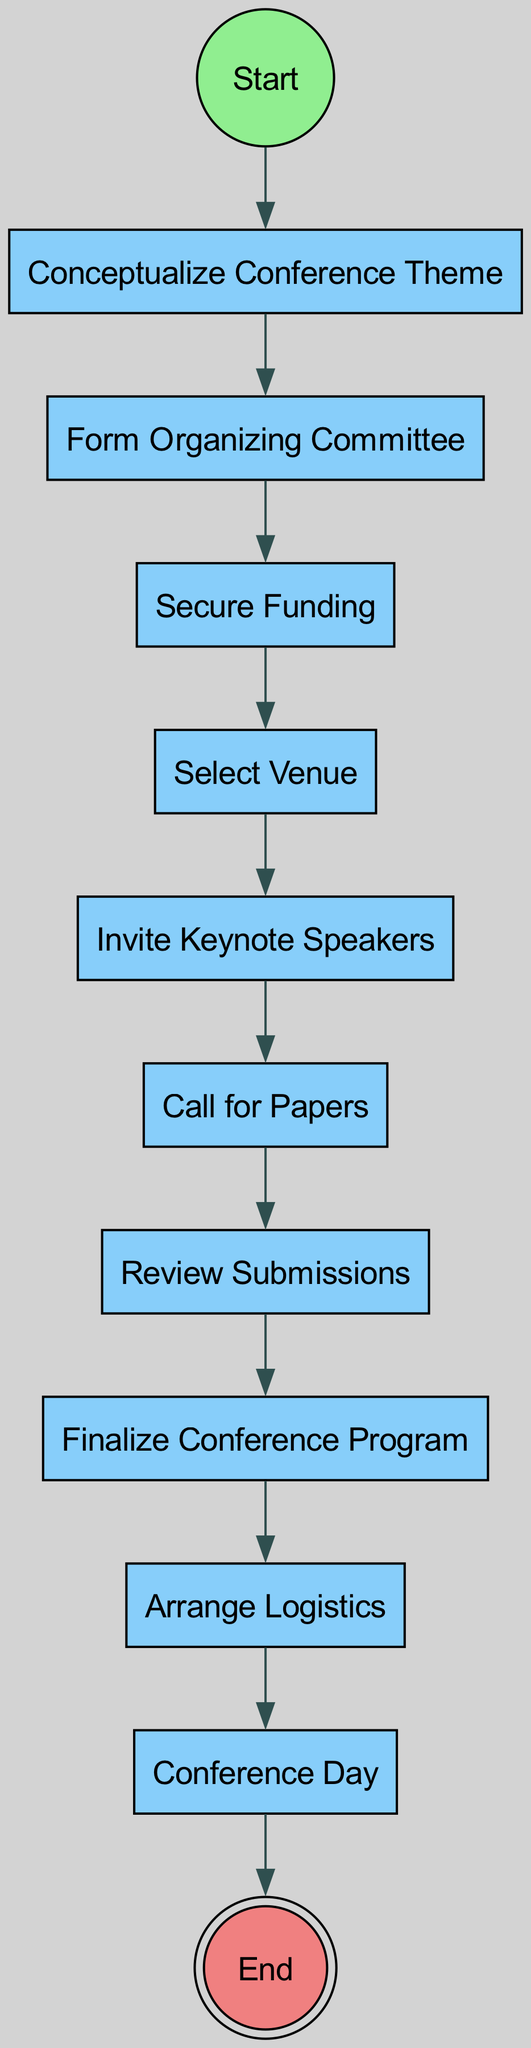What is the first action in the diagram? The first action in the diagram is represented by the node directly connected to the "start" node. In the provided flow, it is "Conceptualize Conference Theme."
Answer: Conceptualize Conference Theme How many actions are involved in the conference organization process? To find the number of actions, we can count the nodes identified as actions in the diagram. There are ten action nodes.
Answer: 10 What is the last action before the conference day? To determine this, we look for the action node that directly leads to "Conference Day." The node that connects to it is "Arrange Logistics."
Answer: Arrange Logistics What node follows the "Call for Papers" action? The node that directly follows "Call for Papers" in the diagram is "Review Submissions," as indicated by the connecting link.
Answer: Review Submissions What action comes after "Secure Funding"? After "Secure Funding," the flow moves to the next action node, which is "Select Venue." This is directly shown in the diagram's connections.
Answer: Select Venue Which node leads to the end of the process? The node that leads to the end of the process is the "Conference Day" node, as it has a direct connection that goes to the "end" node.
Answer: Conference Day How many nodes in total are represented in the diagram? To find the total number of nodes, we count all the nodes listed, including start, actions, and end nodes, resulting in eleven nodes.
Answer: 11 What is the relationship between "Invite Keynote Speakers" and "Review Submissions"? The relationship is sequential; "Invite Keynote Speakers" leads to "Call for Papers," which subsequently leads to "Review Submissions." Thus, they are part of the conference organization flow.
Answer: Sequential What connects the "Finalize Conference Program" and "Arrange Logistics"? The connection between these two nodes is a direct link, meaning "Finalize Conference Program" transitions directly into "Arrange Logistics" in the flow of actions in the diagram.
Answer: Direct link 